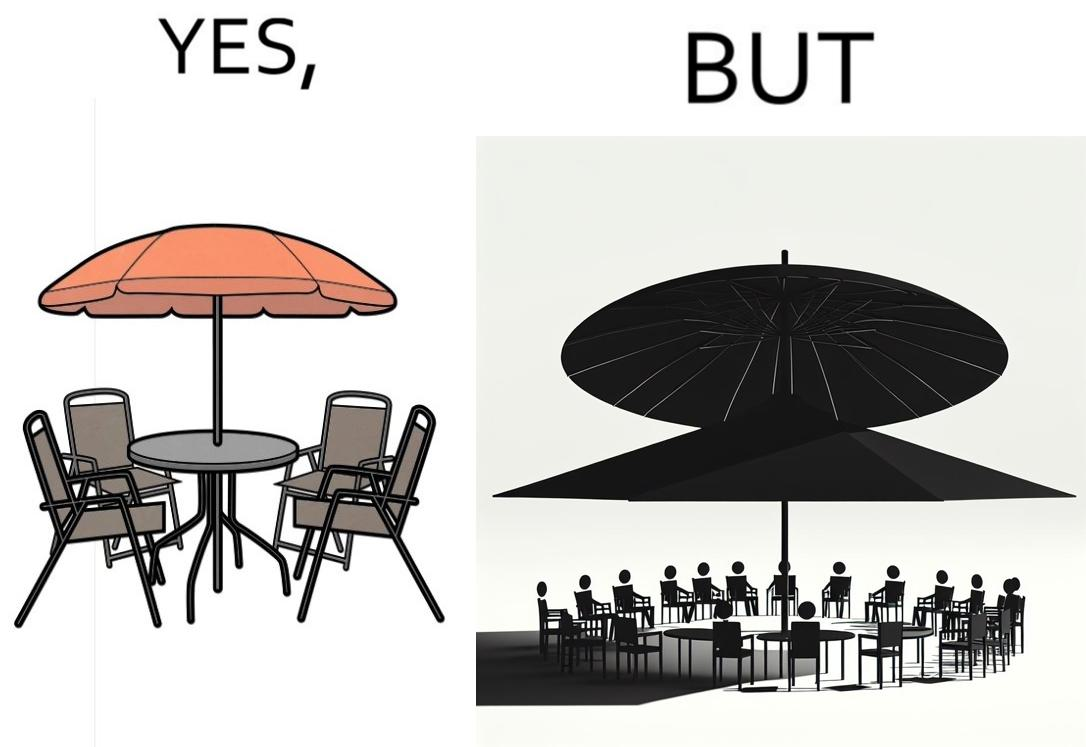Compare the left and right sides of this image. In the left part of the image: Chairs surrounding a table under a large umbrella. In the right part of the image: Chairs surrounding a table under a large umbrella, with the shadow of the umbrella appearing on the side. 